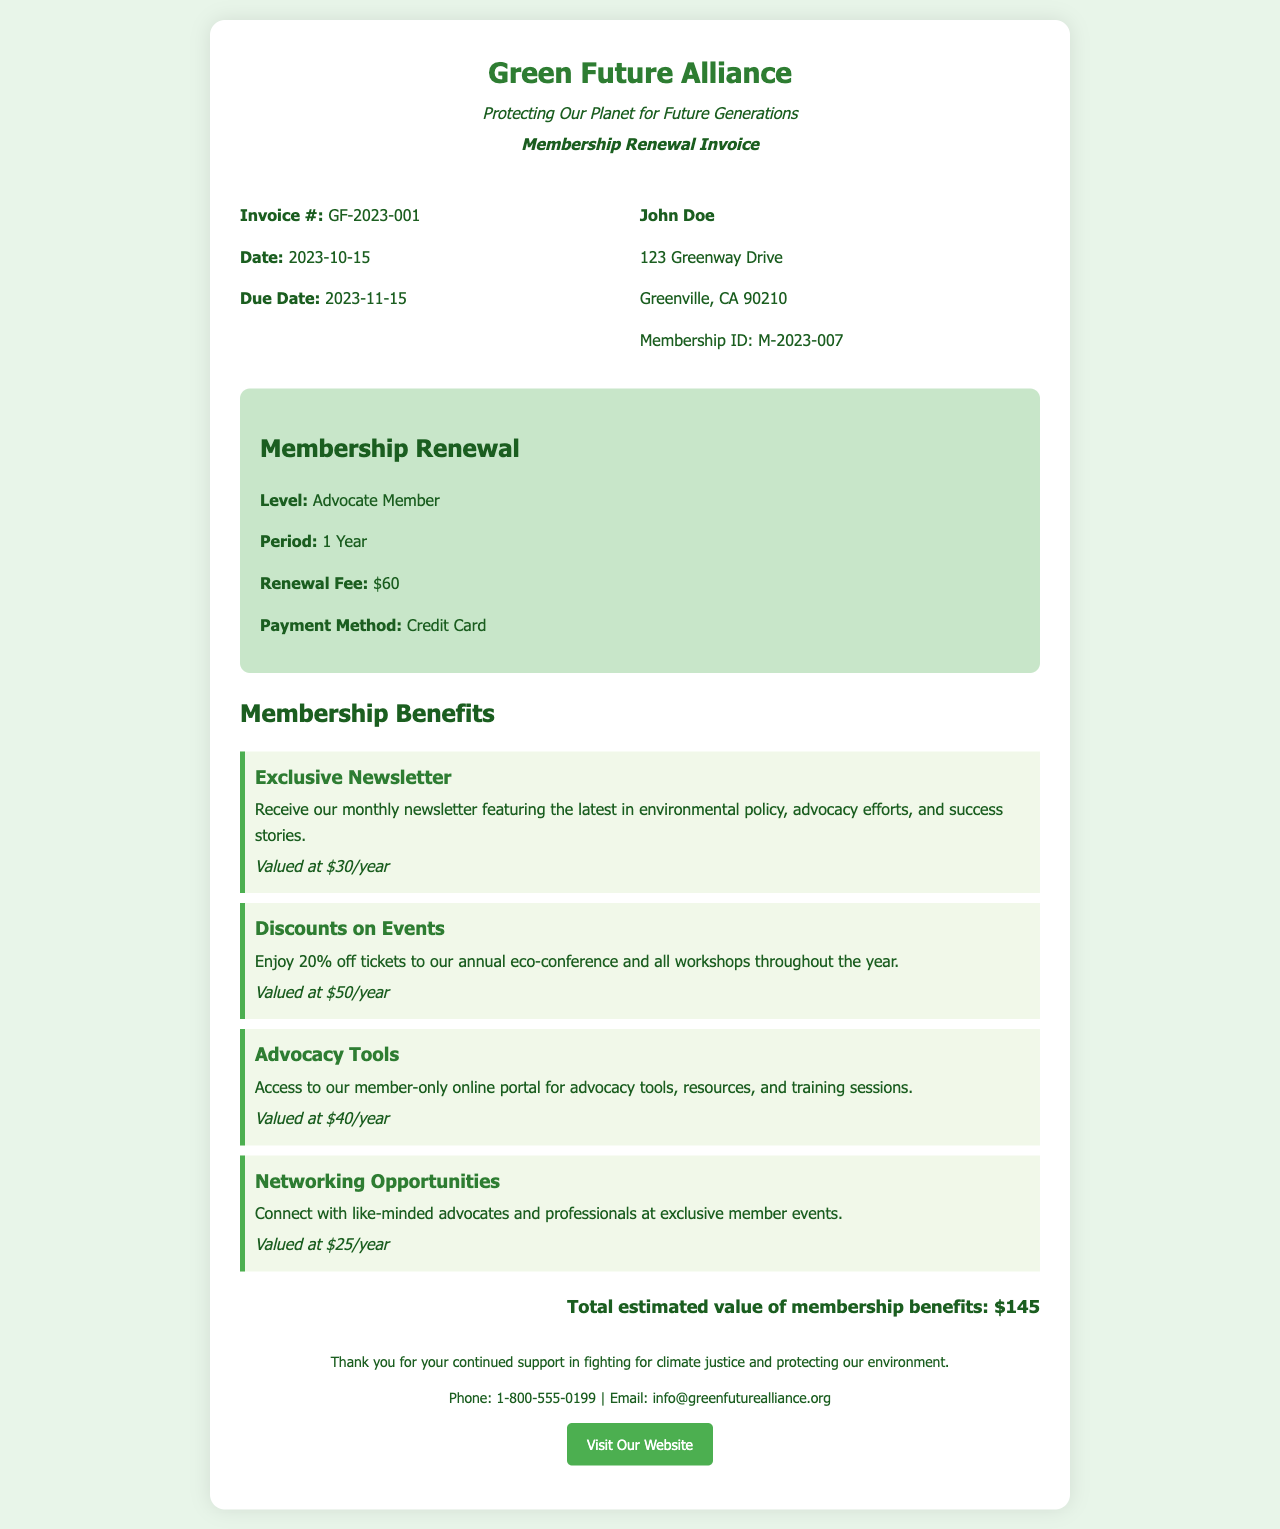what is the invoice number? The invoice number is indicated in the document under the invoice details.
Answer: GF-2023-001 what is the membership level? The membership level can be found in the membership details section of the document.
Answer: Advocate Member what is the renewal fee? The renewal fee is listed in the membership details and indicates the amount due.
Answer: $60 when is the due date for payment? The due date is provided within the invoice details section, indicating when payment is required.
Answer: 2023-11-15 what is the total estimated value of membership benefits? The total estimated value of membership benefits is summarized at the end of the benefits section.
Answer: $145 what is one benefit included in the membership? The benefits listed provide specific advantages of membership; one example can be found in the benefits section.
Answer: Exclusive Newsletter how long is the membership period? The duration of the membership period is specified in the membership details section of the document.
Answer: 1 Year which payment method is used? The accepted payment method is detailed in the membership details section of the document.
Answer: Credit Card how many benefits are listed in the document? The number of benefits is determined by counting the benefits listed in the benefits section.
Answer: 4 